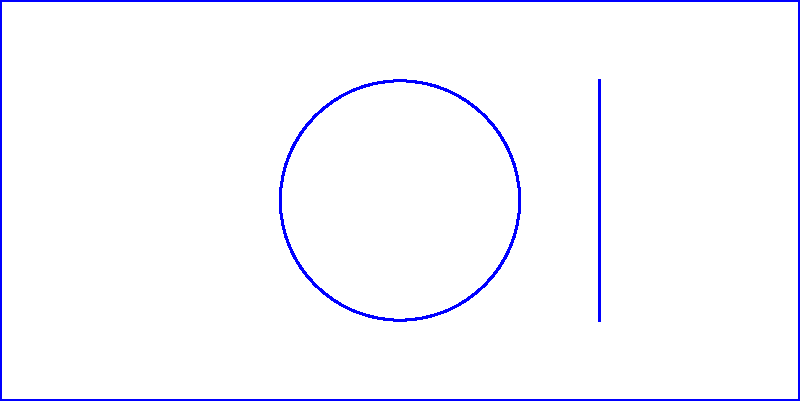As a tech entrepreneur developing a new mobile app, you're working on a user interface (UI) design that needs to be adaptable for various screen orientations. The original UI design is shown in blue. If you apply reflections across both the x-axis and y-axis, how many unique orientations of the UI design will you have in total (including the original)? Let's approach this step-by-step:

1. We start with the original UI design (shown in blue).

2. Reflecting across the x-axis:
   This gives us a new orientation (shown in red dashed lines).

3. Reflecting across the y-axis:
   This gives us another new orientation (shown in green dashed lines).

4. Reflecting across both x and y axes:
   This is equivalent to rotating the original design by 180°. It's shown in orange dotted lines.

5. Count the unique orientations:
   - Original (blue)
   - Reflection across x-axis (red)
   - Reflection across y-axis (green)
   - Reflection across both axes (orange)

6. Analysis:
   Each of these orientations is unique and distinct from the others. The reflection across both axes produces a new orientation that is different from the single-axis reflections.

Therefore, we have 4 unique orientations in total.
Answer: 4 unique orientations 